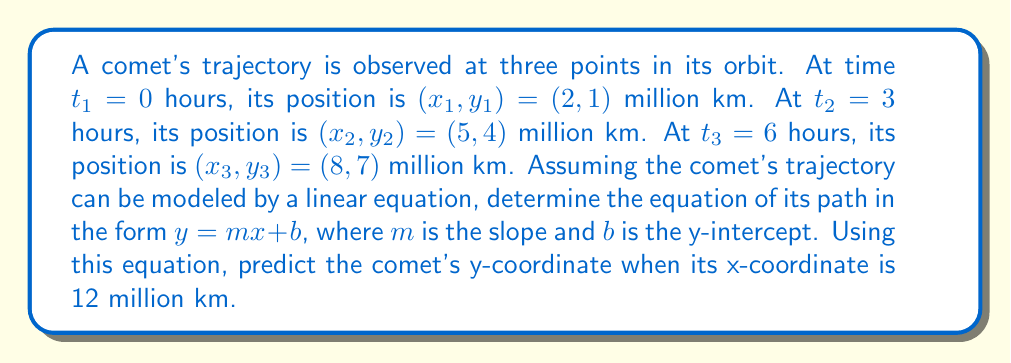Show me your answer to this math problem. To solve this problem, we'll follow these steps:

1) First, we need to find the slope (m) of the line. We can use any two points to calculate this:

   $$m = \frac{y_2 - y_1}{x_2 - x_1} = \frac{4 - 1}{5 - 2} = \frac{3}{3} = 1$$

2) Now that we have the slope, we can use the point-slope form of a line equation to find b:

   $$y - y_1 = m(x - x_1)$$
   $$y - 1 = 1(x - 2)$$
   $$y = x - 2 + 1$$
   $$y = x - 1$$

   So, $b = -1$

3) Our linear equation for the comet's trajectory is:

   $$y = x - 1$$

4) To predict the comet's y-coordinate when x = 12 million km, we simply substitute x = 12 into our equation:

   $$y = 12 - 1 = 11$$

Therefore, when the comet's x-coordinate is 12 million km, its y-coordinate will be 11 million km.
Answer: $y = x - 1$; y = 11 million km when x = 12 million km 